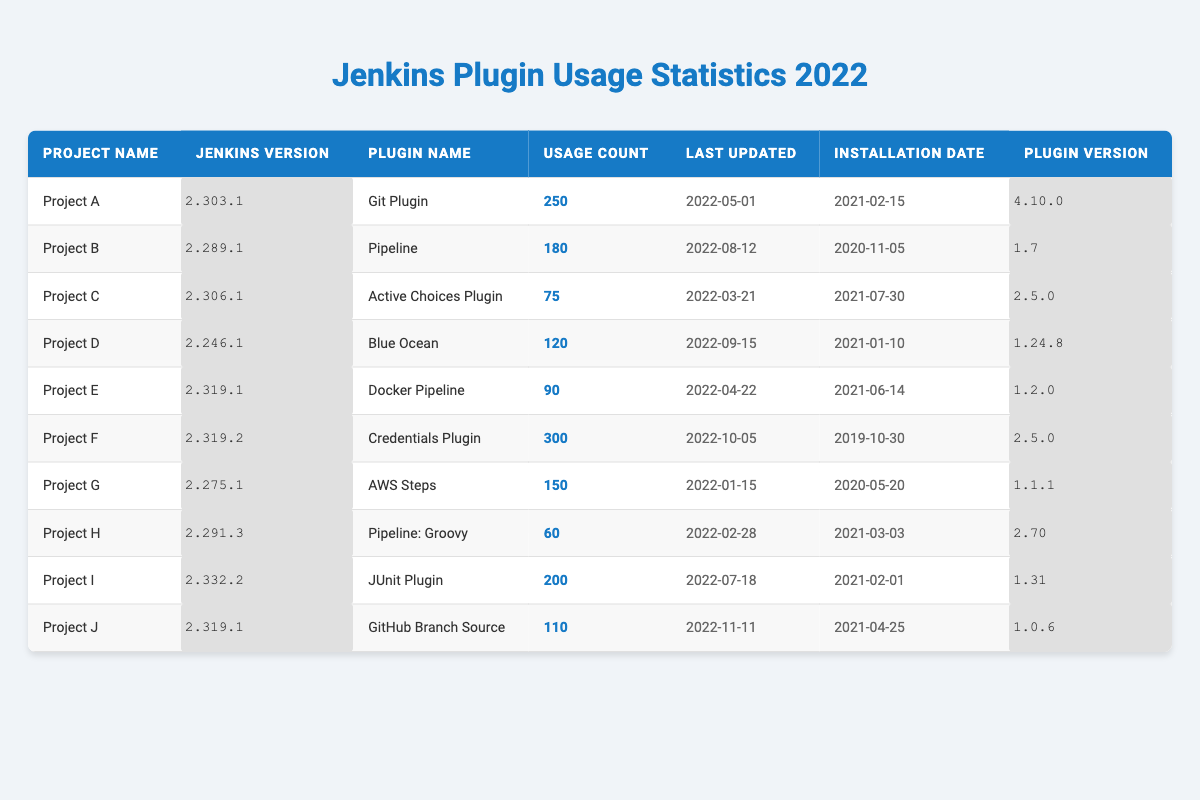What is the usage count of the Git Plugin in Project A? The table lists Project A with the Git Plugin and shows a usage count of 250.
Answer: 250 Which project has the highest usage count for its plugin? By reviewing the usage counts, Project F has the highest usage count at 300 for the Credentials Plugin.
Answer: Project F Is the last updated date for the Active Choices Plugin earlier than that for the Docker Pipeline? The Active Choices Plugin was last updated on 2022-03-21, while the Docker Pipeline was last updated on 2022-04-22. Since March 21 is earlier than April 22, the statement is true.
Answer: Yes How many projects have a plugin usage count greater than 100? The projects with usage counts greater than 100 are Project A (250), Project F (300), Project B (180), Project I (200), and Project G (150). There are 5 projects total.
Answer: 5 What is the average usage count of the plugins? The total usage counts are 250 + 180 + 75 + 120 + 90 + 300 + 150 + 60 + 200 + 110 = 1575. There are 10 projects, so the average usage count is 1575 / 10 = 157.5.
Answer: 157.5 Did any project use a plugin that was installed before 2020? Project F has a Credentials Plugin installed on 2019-10-30, which is before 2020.
Answer: Yes Which projects are using Jenkins version 2.319.x? In the table, Project E and Project F are using Jenkins versions 2.319.1 and 2.319.2 respectively.
Answer: Project E, Project F What is the plugin version used by the AWS Steps plugin? The table indicates that the AWS Steps plugin is using version 1.1.1.
Answer: 1.1.1 Which project has more plugin usage, Project B or Project J? Project B has a usage count of 180, while Project J has a usage count of 110. Comparing these counts, Project B has more usage.
Answer: Project B How many plugins have a usage count less than 100? Looking at the table, only Project C (75) and Project H (60) have usage counts less than 100. Thus, there are 2 plugins.
Answer: 2 